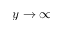Convert formula to latex. <formula><loc_0><loc_0><loc_500><loc_500>y \rightarrow \infty</formula> 